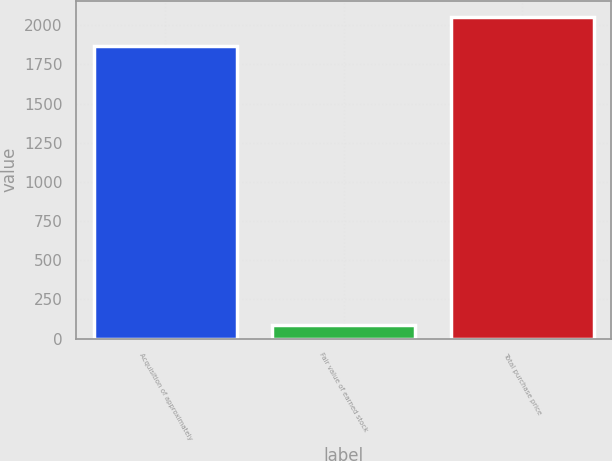Convert chart. <chart><loc_0><loc_0><loc_500><loc_500><bar_chart><fcel>Acquisition of approximately<fcel>Fair value of earned stock<fcel>Total purchase price<nl><fcel>1866<fcel>86<fcel>2052.6<nl></chart> 